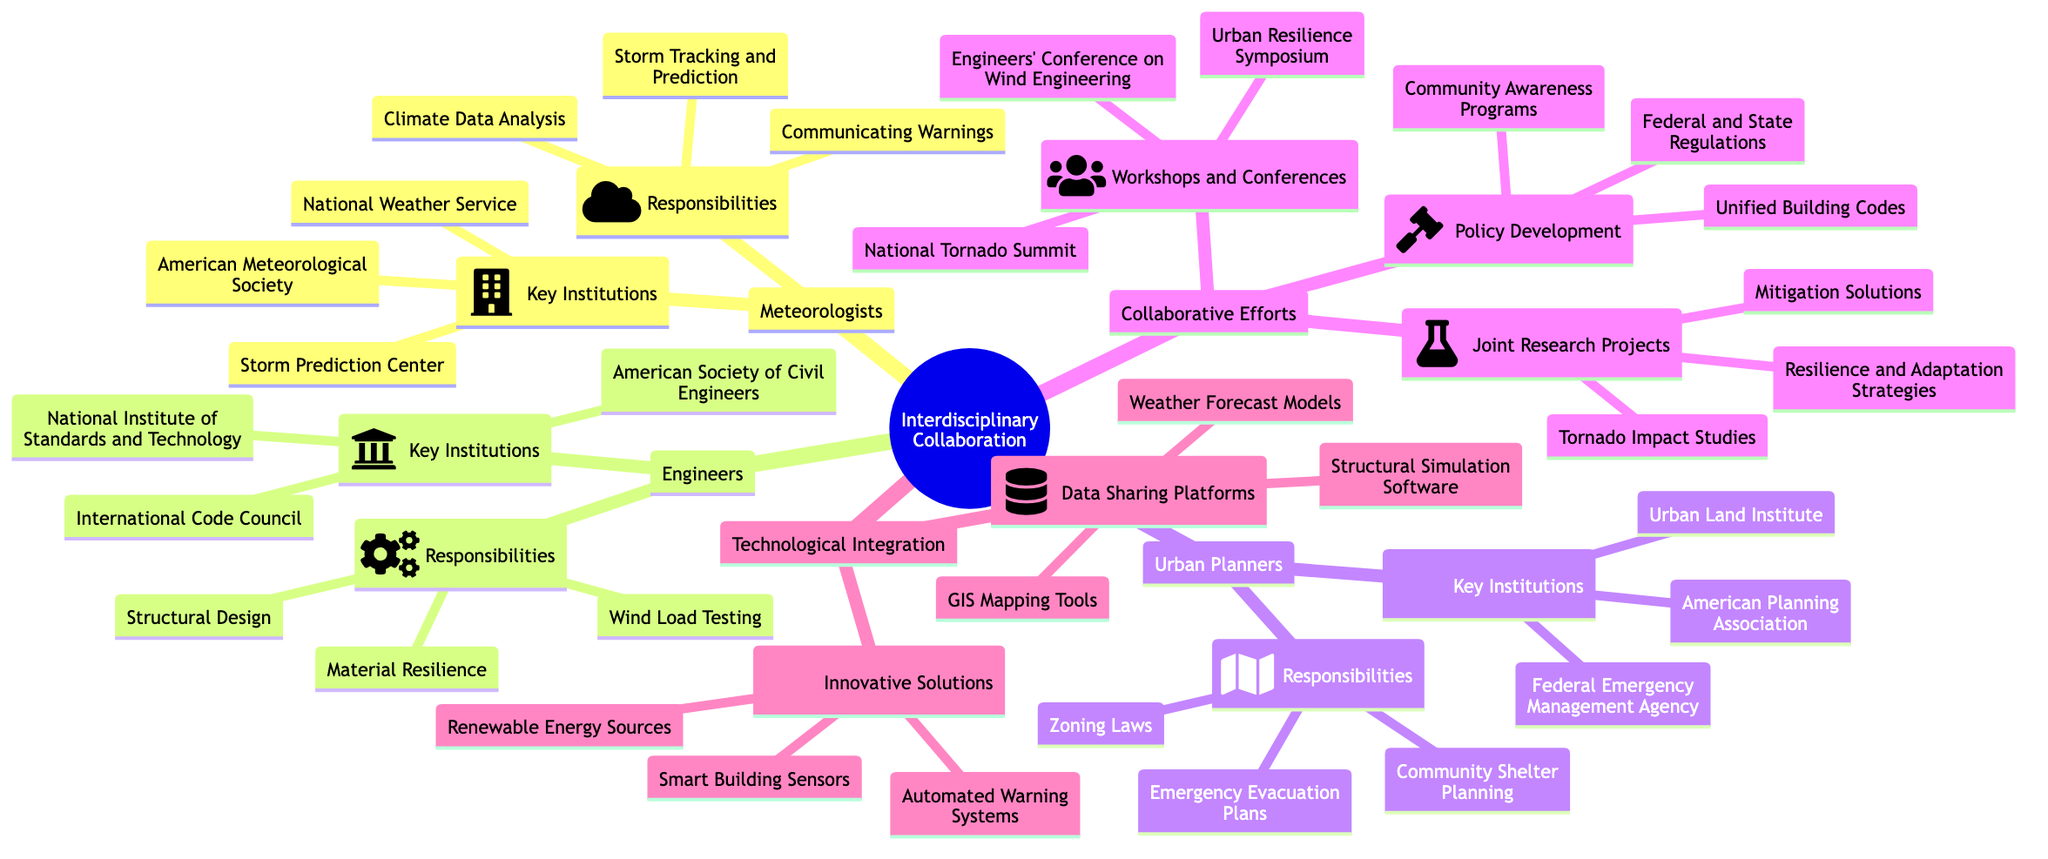What are the responsibilities of meteorologists? The responsibilities of meteorologists are listed under the "Meteorologists" node, showing three specific areas: Storm Tracking and Prediction, Climate Data Analysis, and Communicating Warnings.
Answer: Storm Tracking and Prediction, Climate Data Analysis, Communicating Warnings How many key institutions do engineers have? Under the "Engineers" node, there are three institutions mentioned: American Society of Civil Engineers, National Institute of Standards and Technology, and International Code Council. Therefore, the total number of key institutions for engineers is three.
Answer: 3 What is one of the responsibilities of urban planners? In the "Urban Planners" section, several responsibilities are listed including Zoning Laws, Emergency Evacuation Plans, and Community Shelter Planning. Any of these three can be an answer.
Answer: Zoning Laws Which collaborative effort focuses on community awareness? Under "Collaborative Efforts," the "Policy Development" subsection includes Community Awareness Programs as one of the initiatives aimed at increasing awareness about tornado safety.
Answer: Community Awareness Programs How many joint research projects are mentioned? In the "Collaborative Efforts" section, there are three joint research projects listed: Tornado Impact Studies, Resilience and Adaptation Strategies, and Mitigation Solutions. Therefore, there are three joint research projects mentioned in total.
Answer: 3 Which technological integration includes smart building sensors? The "Innovative Solutions" node under "Technological Integration" mentions Smart Building Sensors as a technological solution, indicating that it is part of this specific category aimed at enhancing tornado safety.
Answer: Smart Building Sensors What event is included in workshops and conferences? In the "Workshops and Conferences" section under "Collaborative Efforts," the National Tornado Summit is explicitly mentioned as one of the events. This indicates it is a key aspect of collaborative efforts among professionals in this domain.
Answer: National Tornado Summit What type of data sharing platforms are listed? The "Data Sharing Platforms" node under "Technological Integration" includes GIS Mapping Tools, Weather Forecast Models, and Structural Simulation Software. Therefore, it consists of three specific types of data sharing platforms.
Answer: GIS Mapping Tools, Weather Forecast Models, Structural Simulation Software 